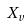Convert formula to latex. <formula><loc_0><loc_0><loc_500><loc_500>X _ { v }</formula> 